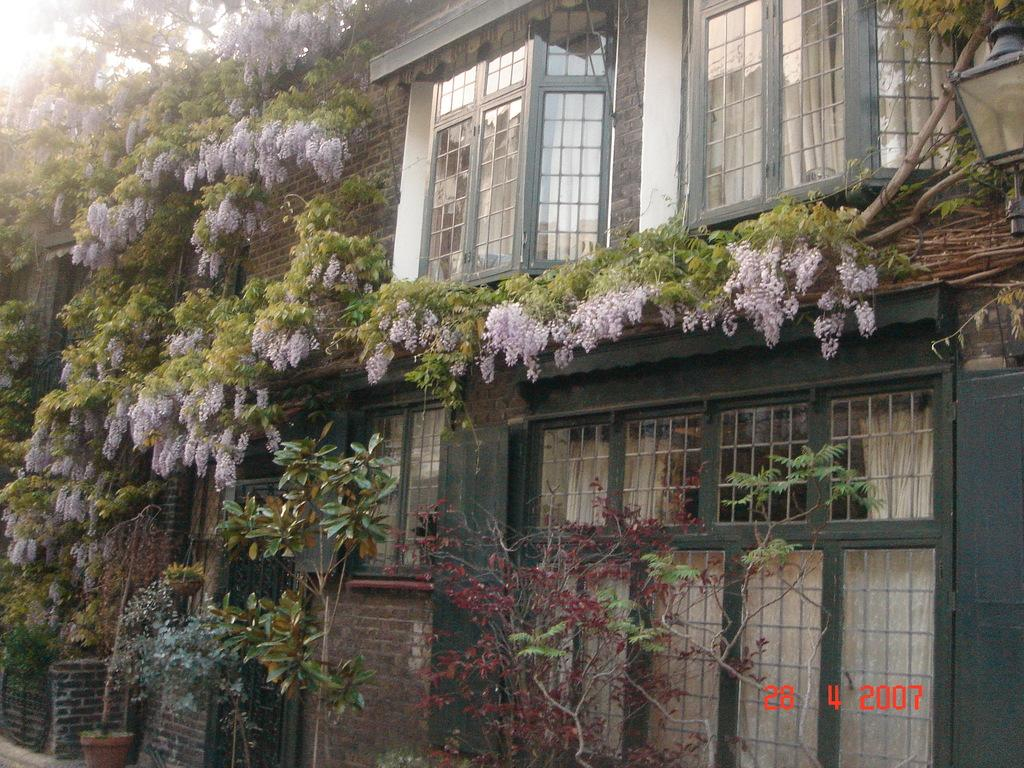What type of structure is present in the image? There is a house in the image. What can be seen around the house? There are plants with beautiful flowers around the house. How many windows are visible on the house? The house has many windows. What object can be seen on the right side of the image? There is a lamp on the right side of the image. What type of grain is being harvested in the image? There is no grain or harvesting activity present in the image; it features a house with plants and a lamp. 